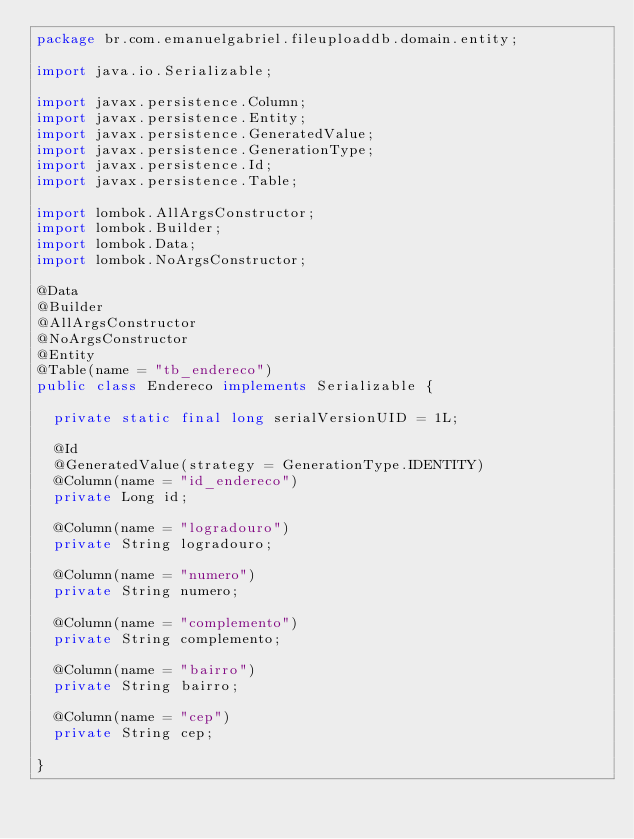Convert code to text. <code><loc_0><loc_0><loc_500><loc_500><_Java_>package br.com.emanuelgabriel.fileuploaddb.domain.entity;

import java.io.Serializable;

import javax.persistence.Column;
import javax.persistence.Entity;
import javax.persistence.GeneratedValue;
import javax.persistence.GenerationType;
import javax.persistence.Id;
import javax.persistence.Table;

import lombok.AllArgsConstructor;
import lombok.Builder;
import lombok.Data;
import lombok.NoArgsConstructor;

@Data
@Builder
@AllArgsConstructor
@NoArgsConstructor
@Entity
@Table(name = "tb_endereco")
public class Endereco implements Serializable {

	private static final long serialVersionUID = 1L;

	@Id
	@GeneratedValue(strategy = GenerationType.IDENTITY)
	@Column(name = "id_endereco")
	private Long id;

	@Column(name = "logradouro")
	private String logradouro;

	@Column(name = "numero")
	private String numero;

	@Column(name = "complemento")
	private String complemento;

	@Column(name = "bairro")
	private String bairro;

	@Column(name = "cep")
	private String cep;

}
</code> 